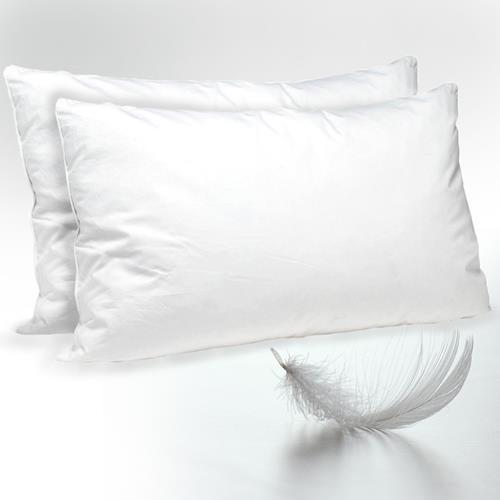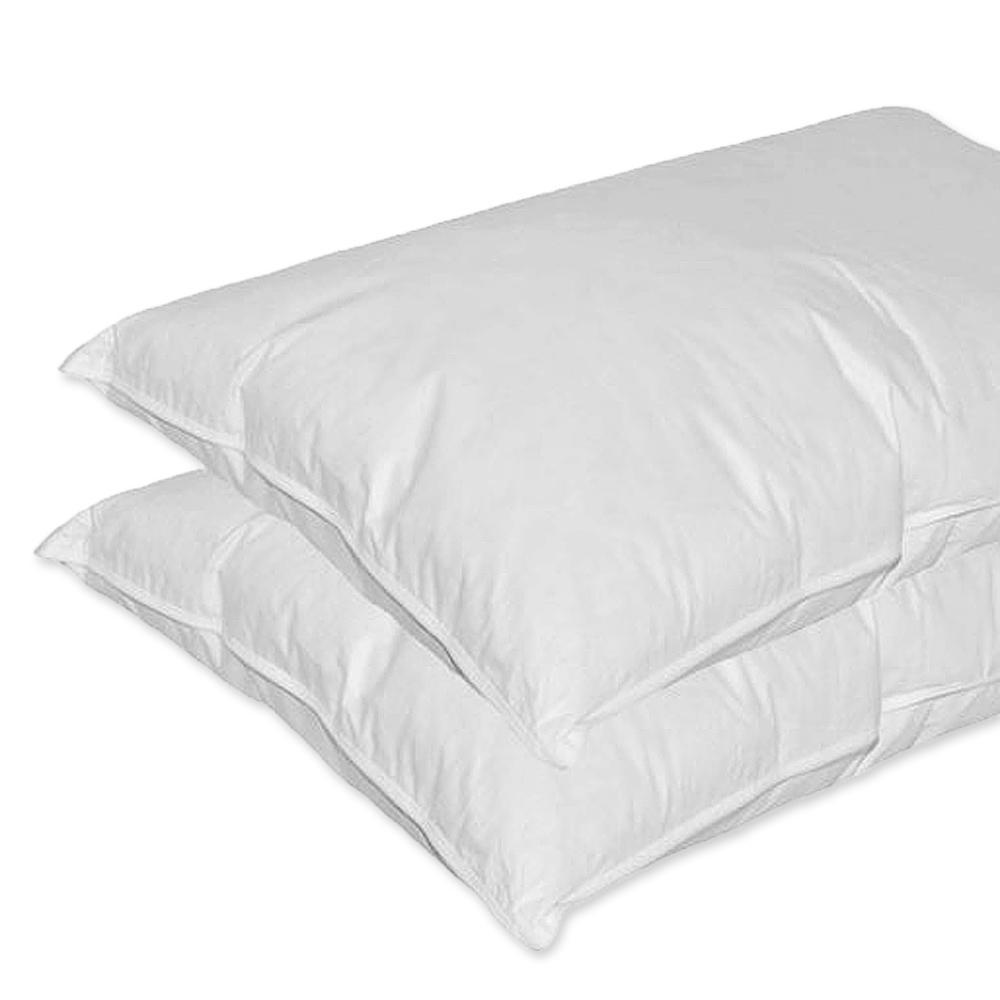The first image is the image on the left, the second image is the image on the right. Given the left and right images, does the statement "Two pillows are stacked on each other in the image on the right." hold true? Answer yes or no. Yes. The first image is the image on the left, the second image is the image on the right. Evaluate the accuracy of this statement regarding the images: "An image with exactly two white pillows includes at least one white feather at the bottom right.". Is it true? Answer yes or no. Yes. 